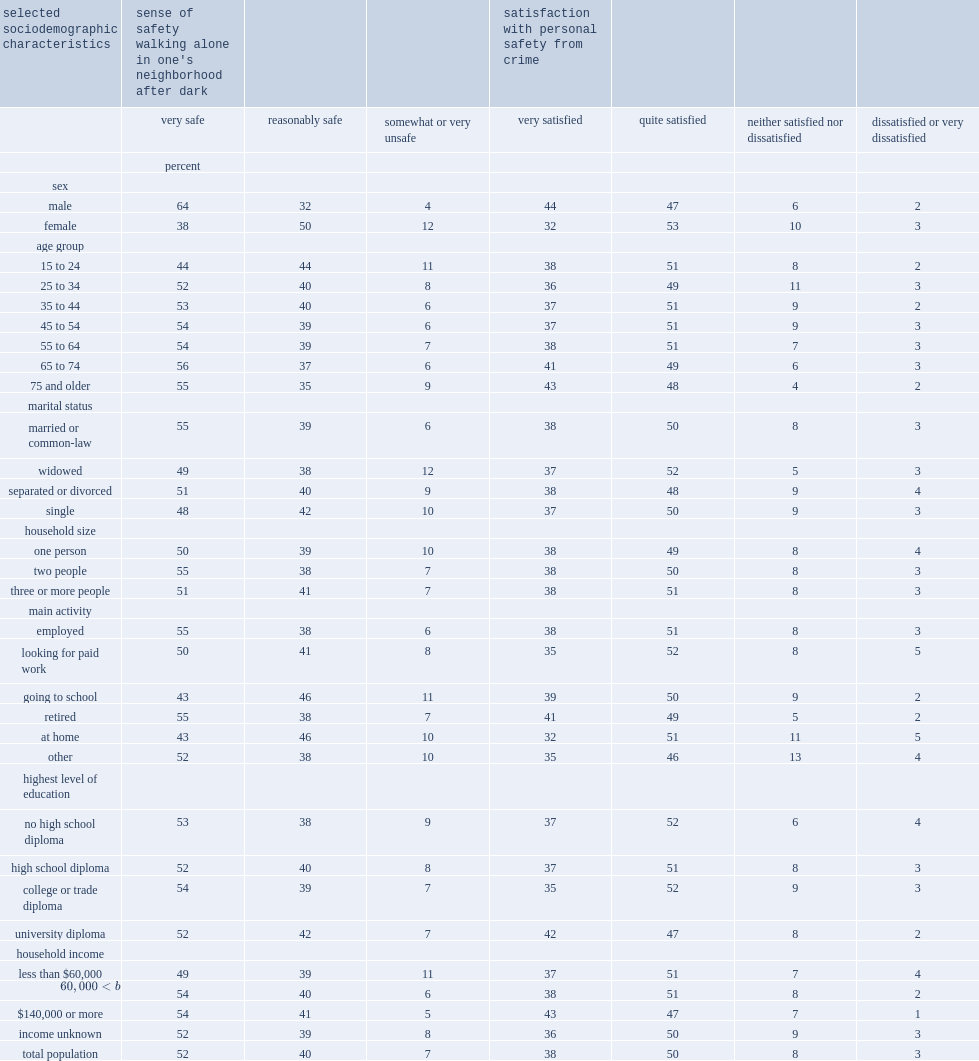I'm looking to parse the entire table for insights. Could you assist me with that? {'header': ['selected sociodemographic characteristics', "sense of safety walking alone in one's neighborhood after dark", '', '', 'satisfaction with personal safety from crime', '', '', ''], 'rows': [['', 'very safe', 'reasonably safe', 'somewhat or very unsafe', 'very satisfied', 'quite satisfied', 'neither satisfied nor dissatisfied', 'dissatisfied or very dissatisfied'], ['', 'percent', '', '', '', '', '', ''], ['sex', '', '', '', '', '', '', ''], ['male', '64', '32', '4', '44', '47', '6', '2'], ['female', '38', '50', '12', '32', '53', '10', '3'], ['age group', '', '', '', '', '', '', ''], ['15 to 24', '44', '44', '11', '38', '51', '8', '2'], ['25 to 34', '52', '40', '8', '36', '49', '11', '3'], ['35 to 44', '53', '40', '6', '37', '51', '9', '2'], ['45 to 54', '54', '39', '6', '37', '51', '9', '3'], ['55 to 64', '54', '39', '7', '38', '51', '7', '3'], ['65 to 74', '56', '37', '6', '41', '49', '6', '3'], ['75 and older', '55', '35', '9', '43', '48', '4', '2'], ['marital status', '', '', '', '', '', '', ''], ['married or common-law', '55', '39', '6', '38', '50', '8', '3'], ['widowed', '49', '38', '12', '37', '52', '5', '3'], ['separated or divorced', '51', '40', '9', '38', '48', '9', '4'], ['single', '48', '42', '10', '37', '50', '9', '3'], ['household size', '', '', '', '', '', '', ''], ['one person', '50', '39', '10', '38', '49', '8', '4'], ['two people', '55', '38', '7', '38', '50', '8', '3'], ['three or more people', '51', '41', '7', '38', '51', '8', '3'], ['main activity', '', '', '', '', '', '', ''], ['employed', '55', '38', '6', '38', '51', '8', '3'], ['looking for paid work', '50', '41', '8', '35', '52', '8', '5'], ['going to school', '43', '46', '11', '39', '50', '9', '2'], ['retired', '55', '38', '7', '41', '49', '5', '2'], ['at home', '43', '46', '10', '32', '51', '11', '5'], ['other', '52', '38', '10', '35', '46', '13', '4'], ['highest level of education', '', '', '', '', '', '', ''], ['no high school diploma', '53', '38', '9', '37', '52', '6', '4'], ['high school diploma', '52', '40', '8', '37', '51', '8', '3'], ['college or trade diploma', '54', '39', '7', '35', '52', '9', '3'], ['university diploma', '52', '42', '7', '42', '47', '8', '2'], ['household income', '', '', '', '', '', '', ''], ['less than $60,000', '49', '39', '11', '37', '51', '7', '4'], ['$60,000 to $139,999', '54', '40', '6', '38', '51', '8', '2'], ['$140,000 or more', '54', '41', '5', '43', '47', '7', '1'], ['income unknown', '52', '39', '8', '36', '50', '9', '3'], ['total population', '52', '40', '7', '38', '50', '8', '3']]} Among women who walk alone in their neighbourhood after dark, what's the percentage of those who said they felt very safe? 38.0. When walking alone in their neighbourhood after dark,how many times did women feel somewhat or very unsafe than men? 3. Which age group was the least likely group to feel very safe when walking alone in their neighbourhood after dark. 15 to 24. 